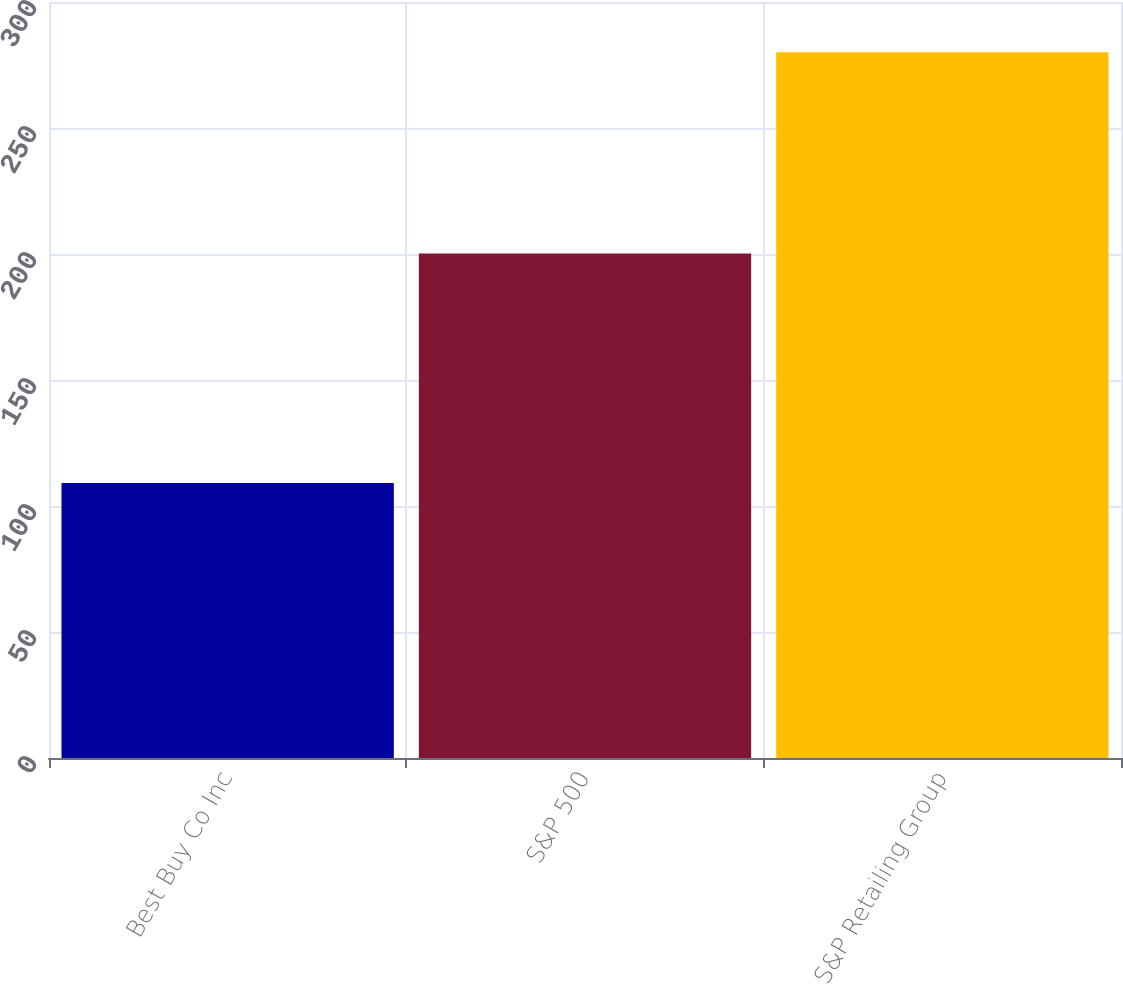Convert chart. <chart><loc_0><loc_0><loc_500><loc_500><bar_chart><fcel>Best Buy Co Inc<fcel>S&P 500<fcel>S&P Retailing Group<nl><fcel>109.09<fcel>200.21<fcel>280.1<nl></chart> 